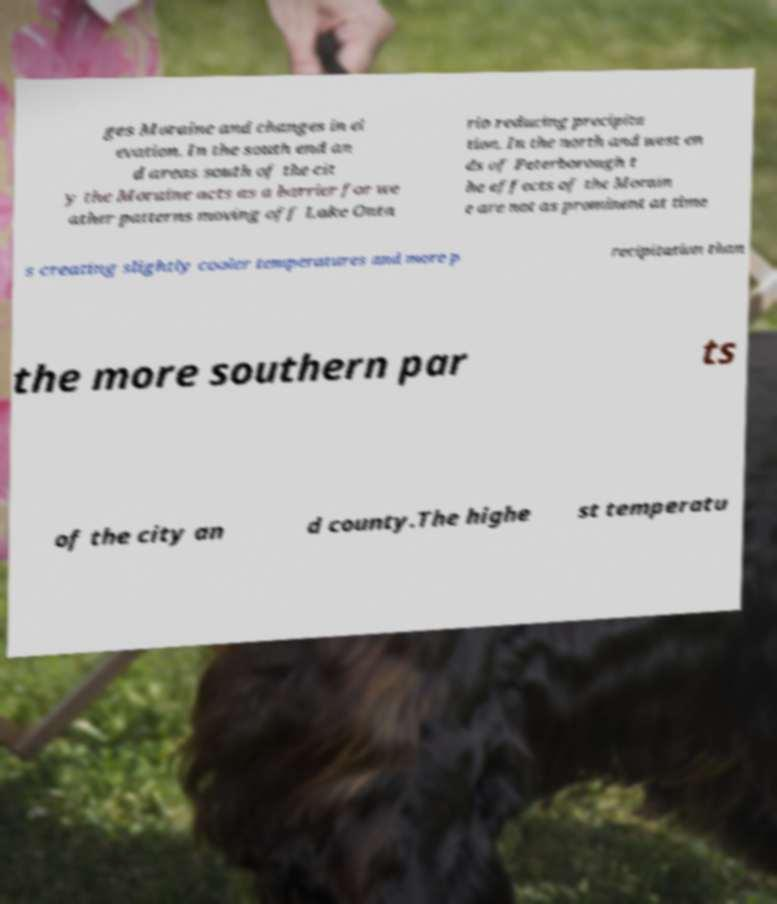Could you extract and type out the text from this image? ges Moraine and changes in el evation. In the south end an d areas south of the cit y the Moraine acts as a barrier for we ather patterns moving off Lake Onta rio reducing precipita tion. In the north and west en ds of Peterborough t he effects of the Morain e are not as prominent at time s creating slightly cooler temperatures and more p recipitation than the more southern par ts of the city an d county.The highe st temperatu 